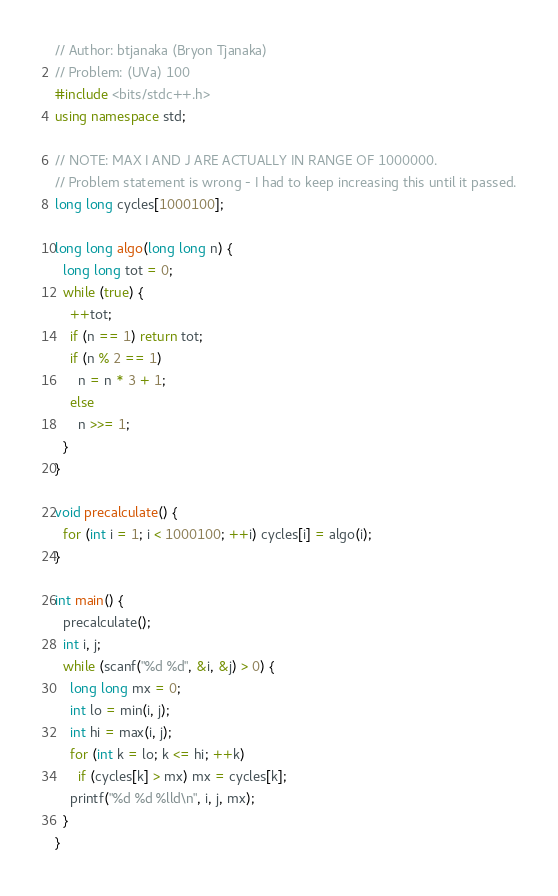<code> <loc_0><loc_0><loc_500><loc_500><_C++_>// Author: btjanaka (Bryon Tjanaka)
// Problem: (UVa) 100
#include <bits/stdc++.h>
using namespace std;

// NOTE: MAX I AND J ARE ACTUALLY IN RANGE OF 1000000.
// Problem statement is wrong - I had to keep increasing this until it passed.
long long cycles[1000100];

long long algo(long long n) {
  long long tot = 0;
  while (true) {
    ++tot;
    if (n == 1) return tot;
    if (n % 2 == 1)
      n = n * 3 + 1;
    else
      n >>= 1;
  }
}

void precalculate() {
  for (int i = 1; i < 1000100; ++i) cycles[i] = algo(i);
}

int main() {
  precalculate();
  int i, j;
  while (scanf("%d %d", &i, &j) > 0) {
    long long mx = 0;
    int lo = min(i, j);
    int hi = max(i, j);
    for (int k = lo; k <= hi; ++k)
      if (cycles[k] > mx) mx = cycles[k];
    printf("%d %d %lld\n", i, j, mx);
  }
}
</code> 